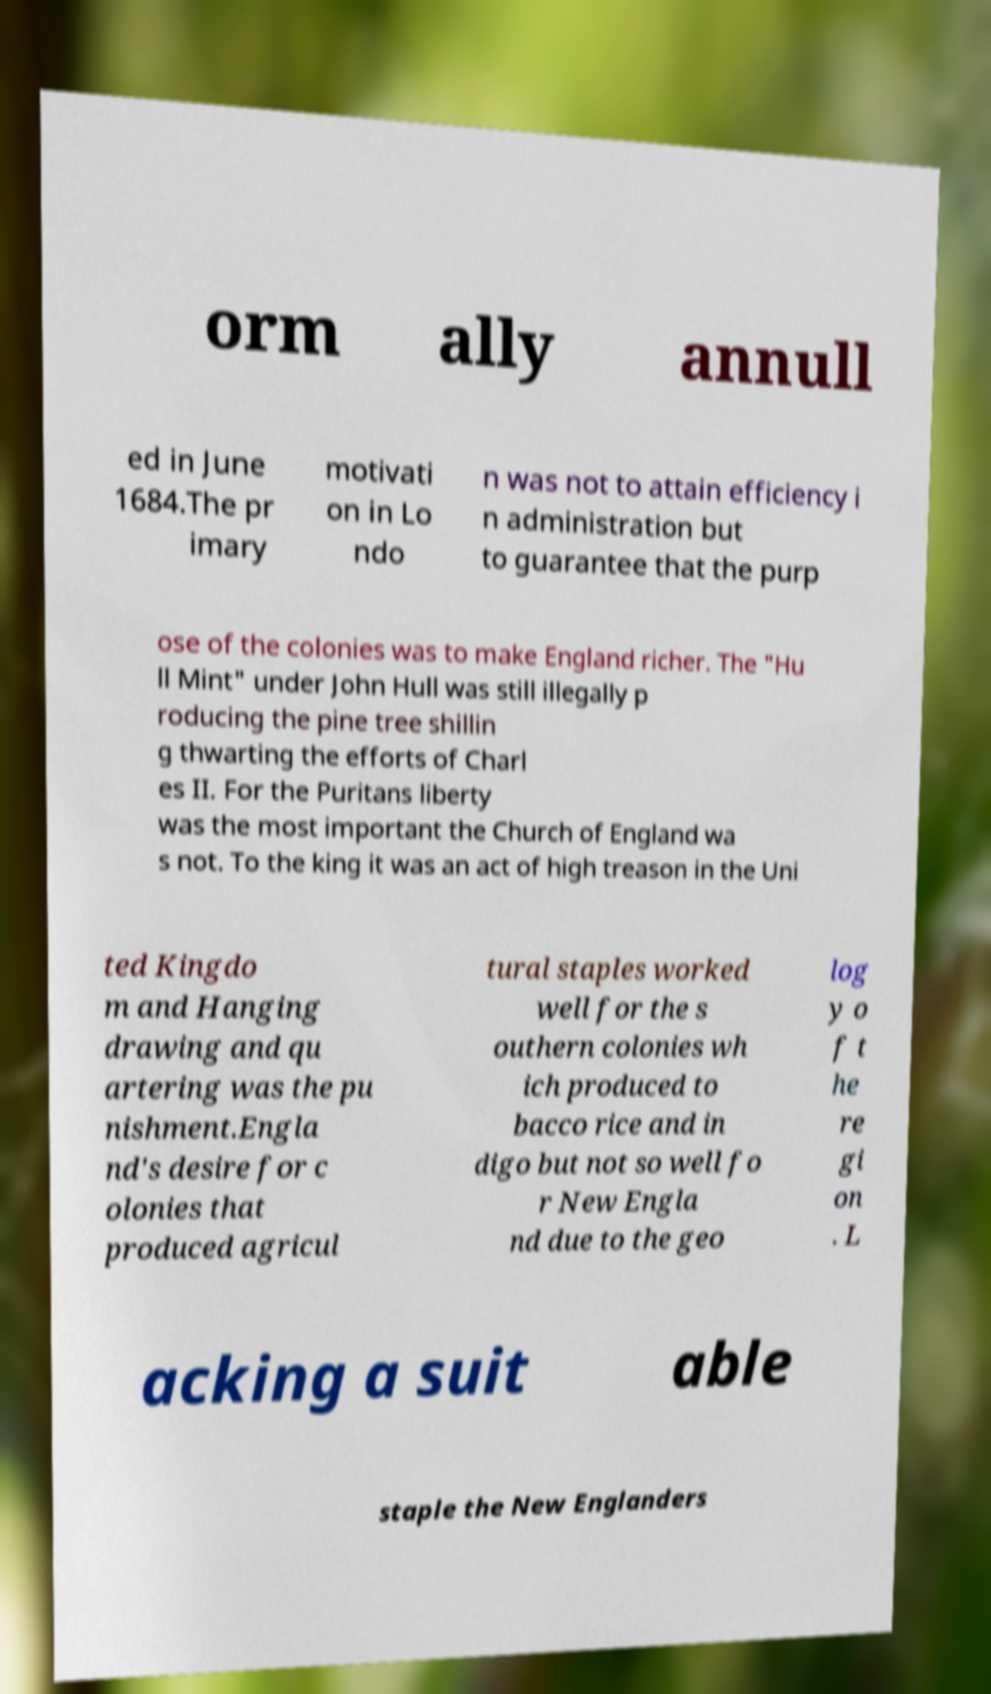I need the written content from this picture converted into text. Can you do that? orm ally annull ed in June 1684.The pr imary motivati on in Lo ndo n was not to attain efficiency i n administration but to guarantee that the purp ose of the colonies was to make England richer. The "Hu ll Mint" under John Hull was still illegally p roducing the pine tree shillin g thwarting the efforts of Charl es II. For the Puritans liberty was the most important the Church of England wa s not. To the king it was an act of high treason in the Uni ted Kingdo m and Hanging drawing and qu artering was the pu nishment.Engla nd's desire for c olonies that produced agricul tural staples worked well for the s outhern colonies wh ich produced to bacco rice and in digo but not so well fo r New Engla nd due to the geo log y o f t he re gi on . L acking a suit able staple the New Englanders 